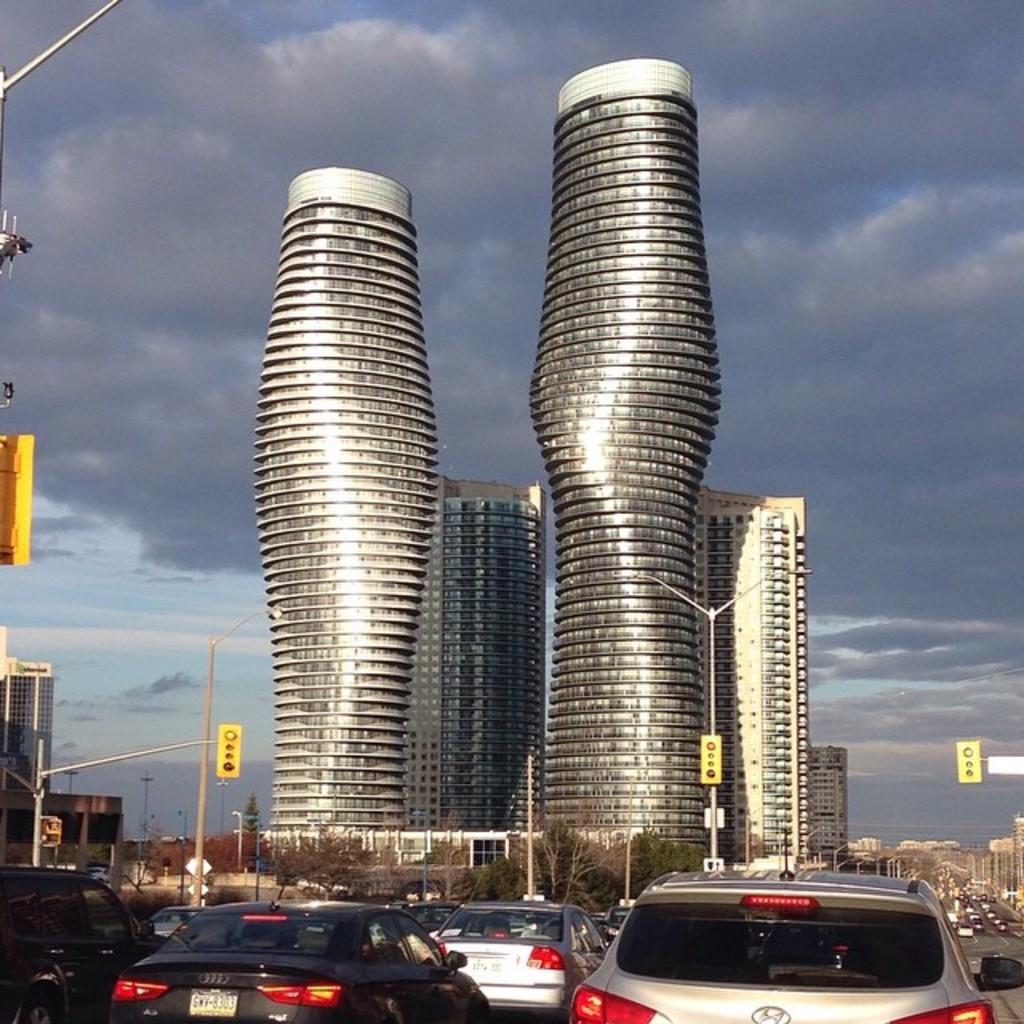What types of objects can be seen in the image? There are vehicles, poles, signal lights, buildings, and trees visible in the image. What is the purpose of the poles in the image? The poles in the image are likely used to support signal lights or other infrastructure. What can be seen in the sky in the image? Clouds and the sky are visible in the image. What type of beam is holding up the trees in the image? There is no beam present in the image; the trees are supported by their own trunks and roots. What suggestion is being made by the signal lights in the image? Signal lights do not make suggestions; they provide information to drivers and pedestrians about traffic conditions. What type of apparatus is being used to control the weather in the image? There is no apparatus present in the image to control the weather; the clouds and sky are natural phenomena. 